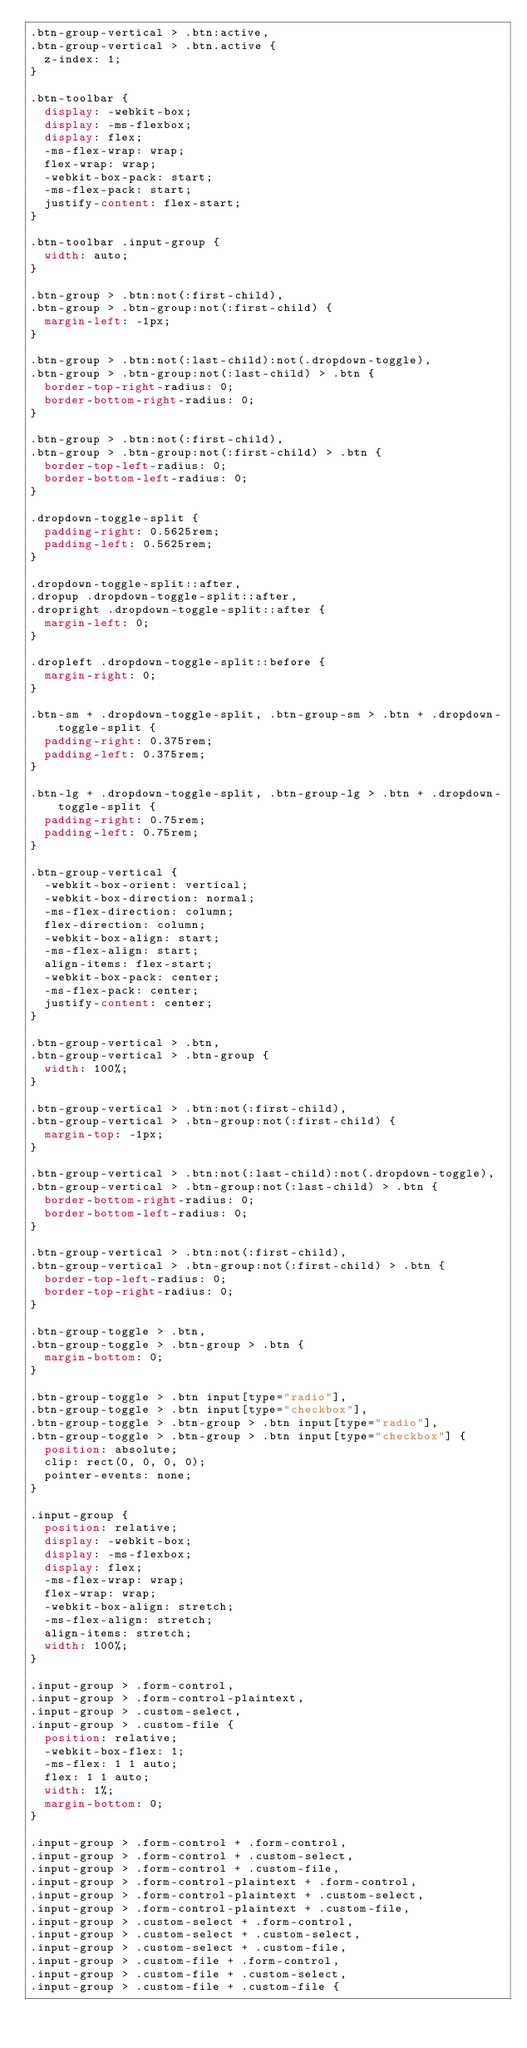<code> <loc_0><loc_0><loc_500><loc_500><_CSS_>.btn-group-vertical > .btn:active,
.btn-group-vertical > .btn.active {
  z-index: 1;
}

.btn-toolbar {
  display: -webkit-box;
  display: -ms-flexbox;
  display: flex;
  -ms-flex-wrap: wrap;
  flex-wrap: wrap;
  -webkit-box-pack: start;
  -ms-flex-pack: start;
  justify-content: flex-start;
}

.btn-toolbar .input-group {
  width: auto;
}

.btn-group > .btn:not(:first-child),
.btn-group > .btn-group:not(:first-child) {
  margin-left: -1px;
}

.btn-group > .btn:not(:last-child):not(.dropdown-toggle),
.btn-group > .btn-group:not(:last-child) > .btn {
  border-top-right-radius: 0;
  border-bottom-right-radius: 0;
}

.btn-group > .btn:not(:first-child),
.btn-group > .btn-group:not(:first-child) > .btn {
  border-top-left-radius: 0;
  border-bottom-left-radius: 0;
}

.dropdown-toggle-split {
  padding-right: 0.5625rem;
  padding-left: 0.5625rem;
}

.dropdown-toggle-split::after,
.dropup .dropdown-toggle-split::after,
.dropright .dropdown-toggle-split::after {
  margin-left: 0;
}

.dropleft .dropdown-toggle-split::before {
  margin-right: 0;
}

.btn-sm + .dropdown-toggle-split, .btn-group-sm > .btn + .dropdown-toggle-split {
  padding-right: 0.375rem;
  padding-left: 0.375rem;
}

.btn-lg + .dropdown-toggle-split, .btn-group-lg > .btn + .dropdown-toggle-split {
  padding-right: 0.75rem;
  padding-left: 0.75rem;
}

.btn-group-vertical {
  -webkit-box-orient: vertical;
  -webkit-box-direction: normal;
  -ms-flex-direction: column;
  flex-direction: column;
  -webkit-box-align: start;
  -ms-flex-align: start;
  align-items: flex-start;
  -webkit-box-pack: center;
  -ms-flex-pack: center;
  justify-content: center;
}

.btn-group-vertical > .btn,
.btn-group-vertical > .btn-group {
  width: 100%;
}

.btn-group-vertical > .btn:not(:first-child),
.btn-group-vertical > .btn-group:not(:first-child) {
  margin-top: -1px;
}

.btn-group-vertical > .btn:not(:last-child):not(.dropdown-toggle),
.btn-group-vertical > .btn-group:not(:last-child) > .btn {
  border-bottom-right-radius: 0;
  border-bottom-left-radius: 0;
}

.btn-group-vertical > .btn:not(:first-child),
.btn-group-vertical > .btn-group:not(:first-child) > .btn {
  border-top-left-radius: 0;
  border-top-right-radius: 0;
}

.btn-group-toggle > .btn,
.btn-group-toggle > .btn-group > .btn {
  margin-bottom: 0;
}

.btn-group-toggle > .btn input[type="radio"],
.btn-group-toggle > .btn input[type="checkbox"],
.btn-group-toggle > .btn-group > .btn input[type="radio"],
.btn-group-toggle > .btn-group > .btn input[type="checkbox"] {
  position: absolute;
  clip: rect(0, 0, 0, 0);
  pointer-events: none;
}

.input-group {
  position: relative;
  display: -webkit-box;
  display: -ms-flexbox;
  display: flex;
  -ms-flex-wrap: wrap;
  flex-wrap: wrap;
  -webkit-box-align: stretch;
  -ms-flex-align: stretch;
  align-items: stretch;
  width: 100%;
}

.input-group > .form-control,
.input-group > .form-control-plaintext,
.input-group > .custom-select,
.input-group > .custom-file {
  position: relative;
  -webkit-box-flex: 1;
  -ms-flex: 1 1 auto;
  flex: 1 1 auto;
  width: 1%;
  margin-bottom: 0;
}

.input-group > .form-control + .form-control,
.input-group > .form-control + .custom-select,
.input-group > .form-control + .custom-file,
.input-group > .form-control-plaintext + .form-control,
.input-group > .form-control-plaintext + .custom-select,
.input-group > .form-control-plaintext + .custom-file,
.input-group > .custom-select + .form-control,
.input-group > .custom-select + .custom-select,
.input-group > .custom-select + .custom-file,
.input-group > .custom-file + .form-control,
.input-group > .custom-file + .custom-select,
.input-group > .custom-file + .custom-file {</code> 